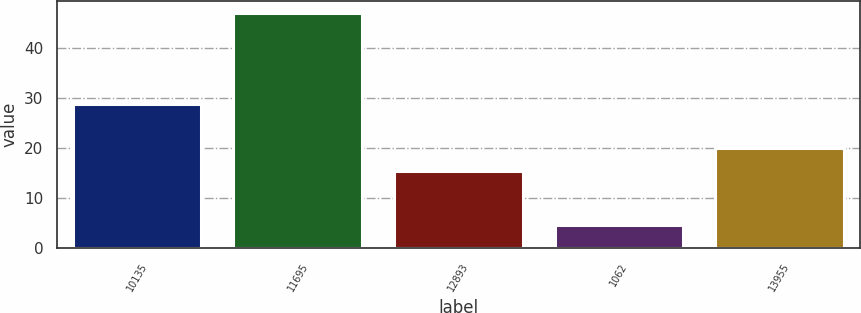<chart> <loc_0><loc_0><loc_500><loc_500><bar_chart><fcel>10135<fcel>11695<fcel>12893<fcel>1062<fcel>13955<nl><fcel>28.7<fcel>47<fcel>15.4<fcel>4.6<fcel>20<nl></chart> 